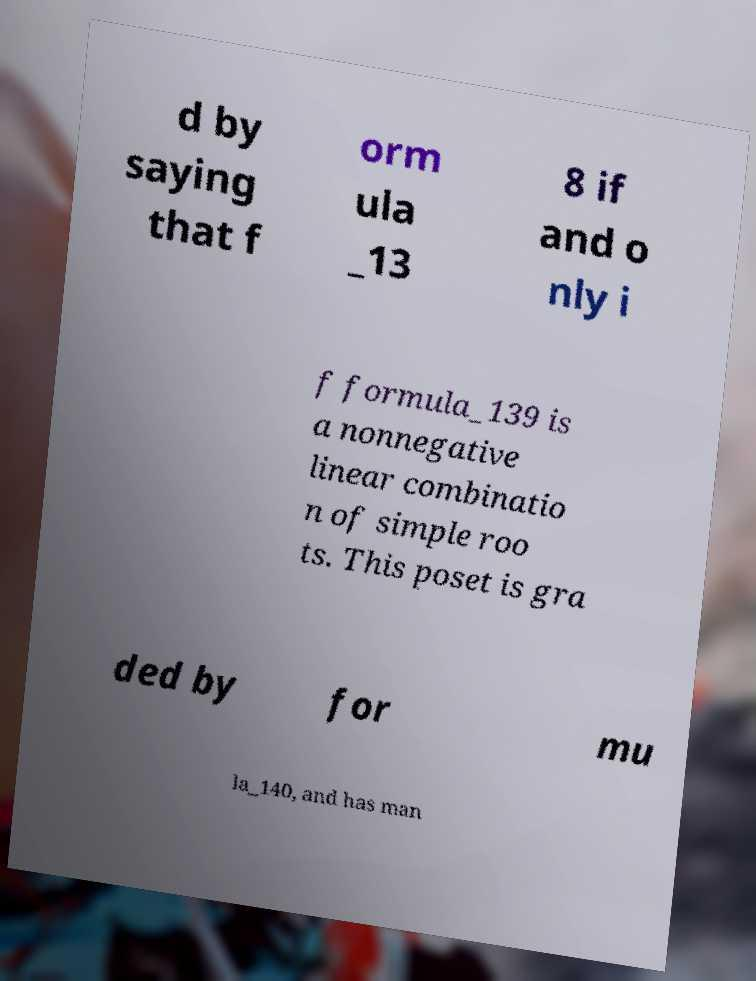What messages or text are displayed in this image? I need them in a readable, typed format. d by saying that f orm ula _13 8 if and o nly i f formula_139 is a nonnegative linear combinatio n of simple roo ts. This poset is gra ded by for mu la_140, and has man 